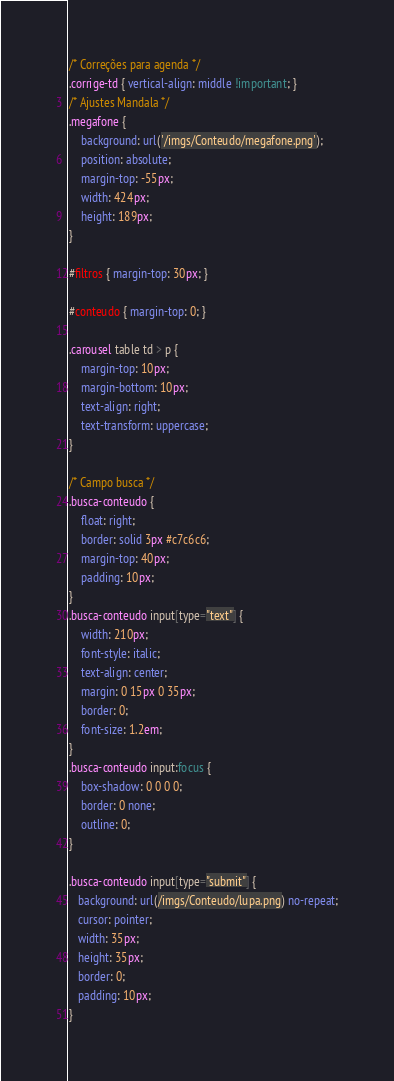<code> <loc_0><loc_0><loc_500><loc_500><_CSS_>/* Correções para agenda */
.corrige-td { vertical-align: middle !important; }
/* Ajustes Mandala */
.megafone {
    background: url('/imgs/Conteudo/megafone.png');
    position: absolute;
    margin-top: -55px;
    width: 424px;
    height: 189px;
}

#filtros { margin-top: 30px; }

#conteudo { margin-top: 0; }

.carousel table td > p {
    margin-top: 10px;
    margin-bottom: 10px;
    text-align: right;
    text-transform: uppercase;
}

/* Campo busca */
.busca-conteudo {
    float: right;
    border: solid 3px #c7c6c6;
    margin-top: 40px;
    padding: 10px;
}
.busca-conteudo input[type="text"] {
    width: 210px;
    font-style: italic;
    text-align: center;
    margin: 0 15px 0 35px;
    border: 0;
    font-size: 1.2em;
}
.busca-conteudo input:focus {
    box-shadow: 0 0 0 0;
    border: 0 none;
    outline: 0;
}

.busca-conteudo input[type="submit"] {
   background: url(/imgs/Conteudo/lupa.png) no-repeat;
   cursor: pointer;
   width: 35px;
   height: 35px;
   border: 0;
   padding: 10px;
}
</code> 